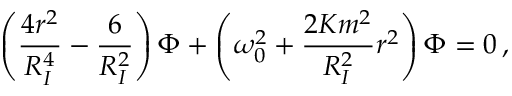Convert formula to latex. <formula><loc_0><loc_0><loc_500><loc_500>\left ( \frac { 4 r ^ { 2 } } { R _ { I } ^ { 4 } } - \frac { 6 } { R _ { I } ^ { 2 } } \right ) \Phi + \left ( \omega _ { 0 } ^ { 2 } + \frac { 2 K m ^ { 2 } } { R _ { I } ^ { 2 } } r ^ { 2 } \right ) \Phi = 0 \, ,</formula> 